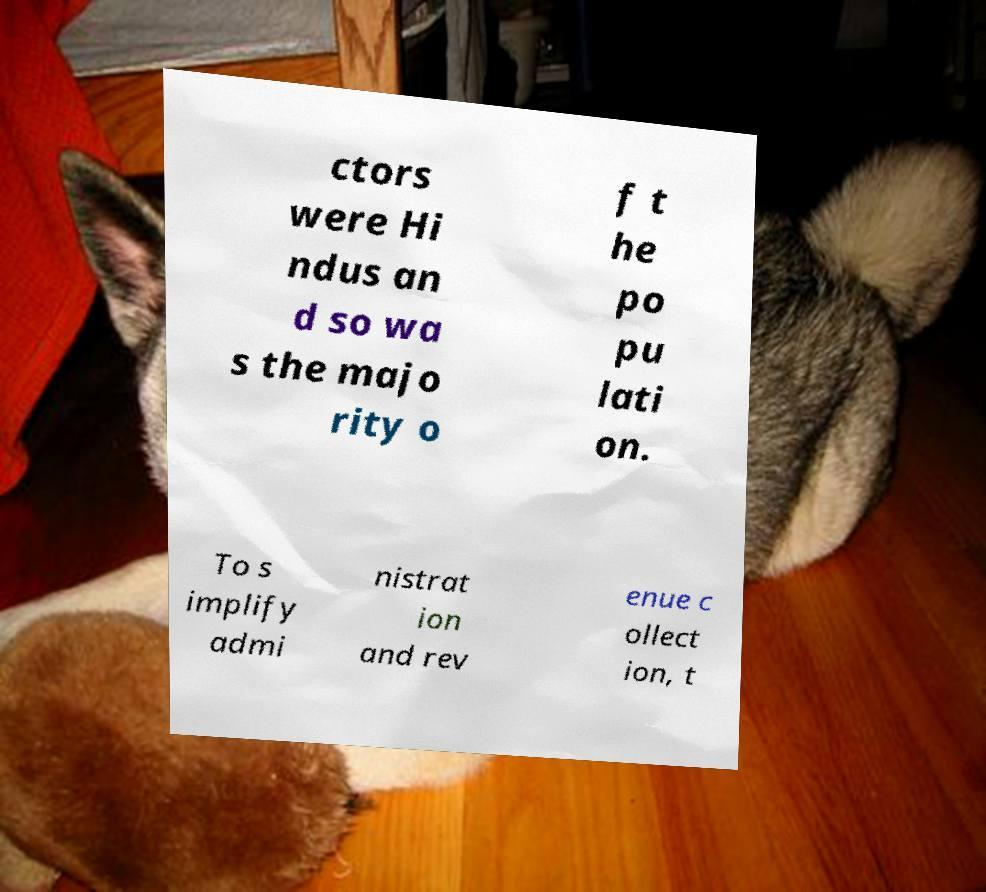Please identify and transcribe the text found in this image. ctors were Hi ndus an d so wa s the majo rity o f t he po pu lati on. To s implify admi nistrat ion and rev enue c ollect ion, t 